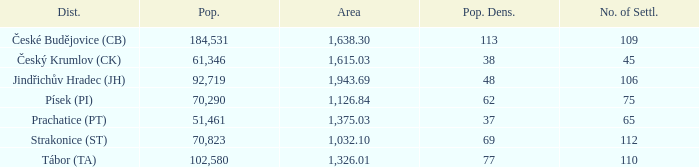What is the lowest population density of Strakonice (st) with more than 112 settlements? None. 